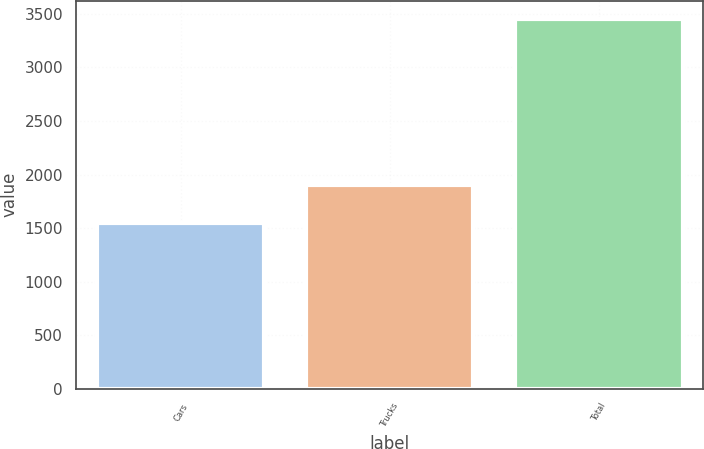Convert chart. <chart><loc_0><loc_0><loc_500><loc_500><bar_chart><fcel>Cars<fcel>Trucks<fcel>Total<nl><fcel>1543<fcel>1906<fcel>3449<nl></chart> 